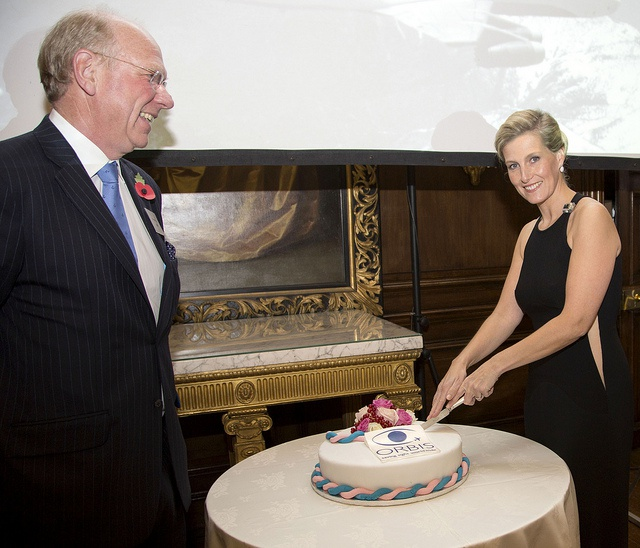Describe the objects in this image and their specific colors. I can see people in darkgray, black, lightpink, and lightgray tones, people in darkgray, black, and tan tones, dining table in darkgray, lightgray, and tan tones, cake in darkgray, lightgray, and tan tones, and tie in darkgray and gray tones in this image. 